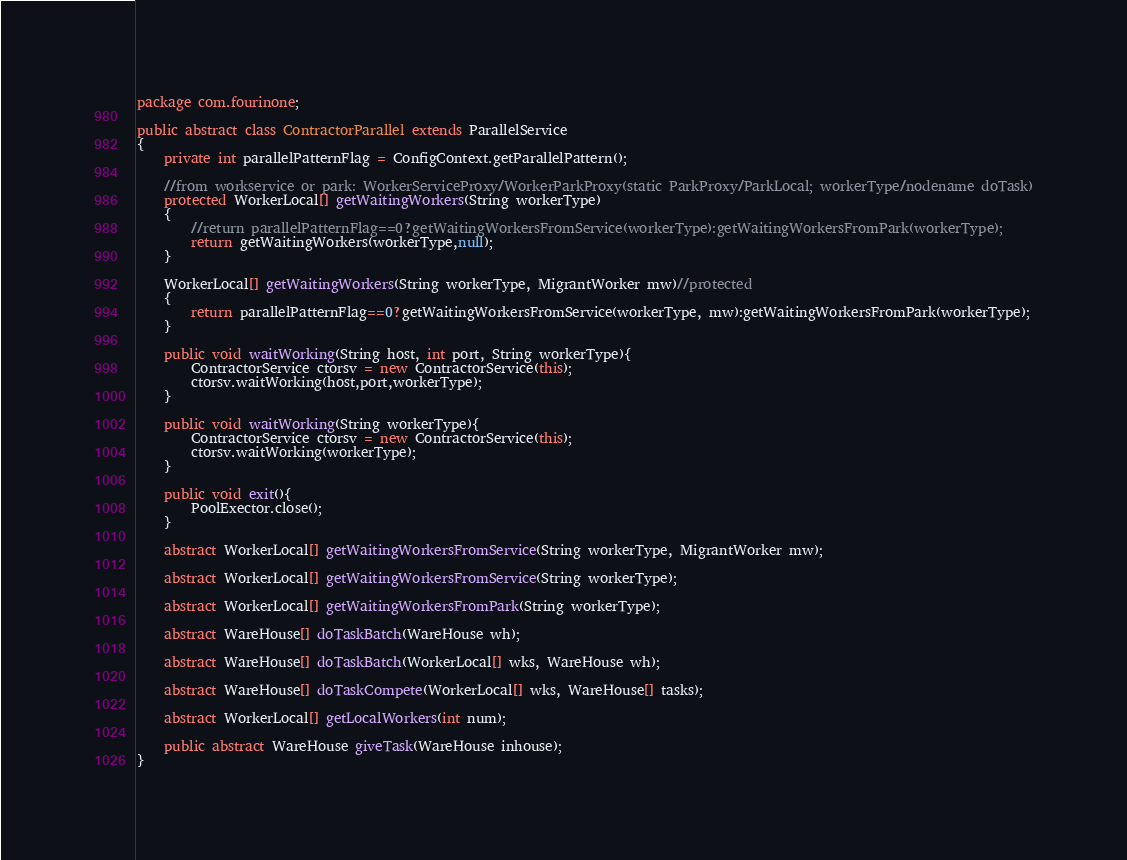<code> <loc_0><loc_0><loc_500><loc_500><_Java_>package com.fourinone;

public abstract class ContractorParallel extends ParallelService
{
	private int parallelPatternFlag = ConfigContext.getParallelPattern();
	
	//from workservice or park: WorkerServiceProxy/WorkerParkProxy(static ParkProxy/ParkLocal; workerType/nodename doTask)
	protected WorkerLocal[] getWaitingWorkers(String workerType)
	{
		//return parallelPatternFlag==0?getWaitingWorkersFromService(workerType):getWaitingWorkersFromPark(workerType);
		return getWaitingWorkers(workerType,null);
	}
	
	WorkerLocal[] getWaitingWorkers(String workerType, MigrantWorker mw)//protected
	{
		return parallelPatternFlag==0?getWaitingWorkersFromService(workerType, mw):getWaitingWorkersFromPark(workerType);
	}
	
	public void waitWorking(String host, int port, String workerType){
		ContractorService ctorsv = new ContractorService(this);
		ctorsv.waitWorking(host,port,workerType);
	}
	
	public void waitWorking(String workerType){
		ContractorService ctorsv = new ContractorService(this);
		ctorsv.waitWorking(workerType);
	}
	
	public void exit(){
		PoolExector.close();
	}
	
	abstract WorkerLocal[] getWaitingWorkersFromService(String workerType, MigrantWorker mw);
	
	abstract WorkerLocal[] getWaitingWorkersFromService(String workerType);
	
	abstract WorkerLocal[] getWaitingWorkersFromPark(String workerType);
	
	abstract WareHouse[] doTaskBatch(WareHouse wh);
	
	abstract WareHouse[] doTaskBatch(WorkerLocal[] wks, WareHouse wh);
	
	abstract WareHouse[] doTaskCompete(WorkerLocal[] wks, WareHouse[] tasks);
	
	abstract WorkerLocal[] getLocalWorkers(int num);
		
	public abstract WareHouse giveTask(WareHouse inhouse);
}</code> 